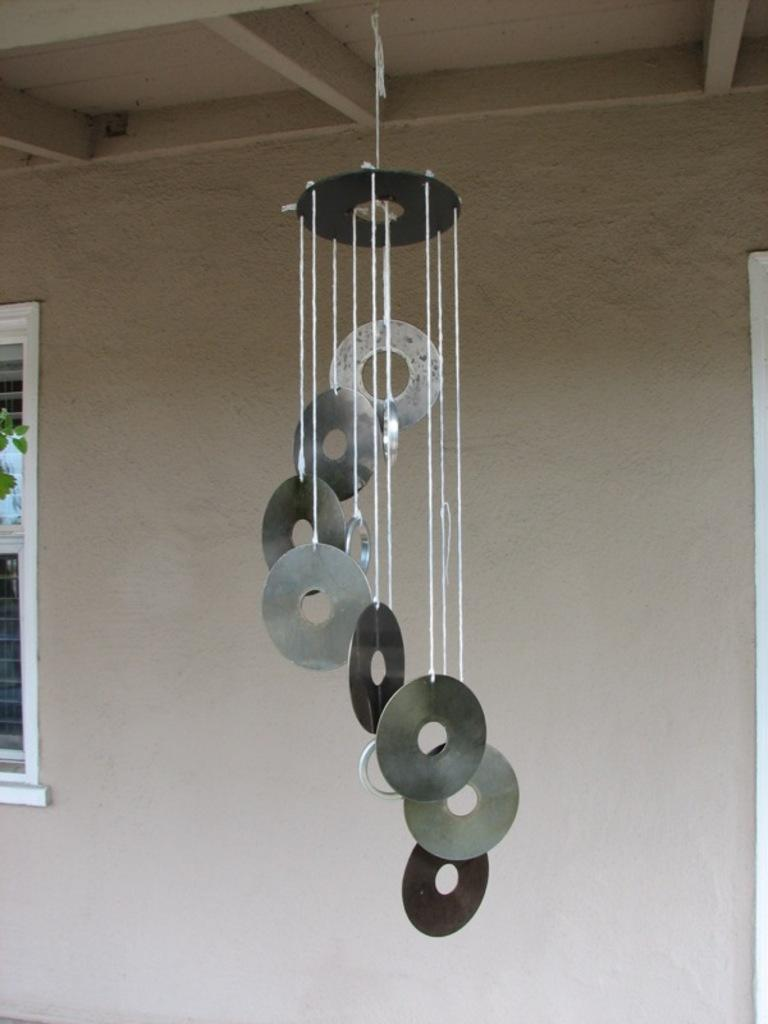What is hanging from the ceiling in the image? There is a wind chime hanging from the ceiling in the image. Where is the window located in the image? The window is on the left side of the image. What can be seen in the background of the image? There is a wall visible in the background of the image. What type of umbrella is being used by the writer in the image? There is no writer or umbrella present in the image. 